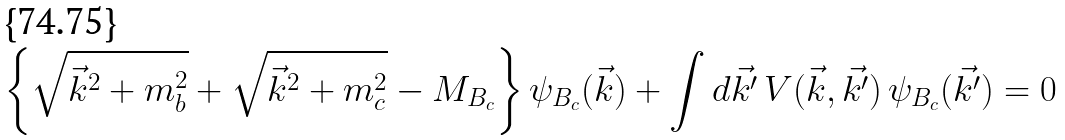<formula> <loc_0><loc_0><loc_500><loc_500>\left \{ \sqrt { \vec { k } ^ { 2 } + m _ { b } ^ { 2 } } + \sqrt { \vec { k } ^ { 2 } + m _ { c } ^ { 2 } } - M _ { B _ { c } } \right \} \psi _ { B _ { c } } ( \vec { k } ) + \int d \vec { k ^ { \prime } } \, V ( \vec { k } , \vec { k ^ { \prime } } ) \, \psi _ { B _ { c } } ( \vec { k ^ { \prime } } ) = 0</formula> 